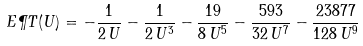Convert formula to latex. <formula><loc_0><loc_0><loc_500><loc_500>E \P T ( U ) = - \frac { 1 } { 2 \, U } - \frac { 1 } { 2 \, U ^ { 3 } } - \frac { 1 9 } { 8 \, U ^ { 5 } } - \frac { 5 9 3 } { 3 2 \, U ^ { 7 } } - \frac { 2 3 8 7 7 } { 1 2 8 \, U ^ { 9 } }</formula> 